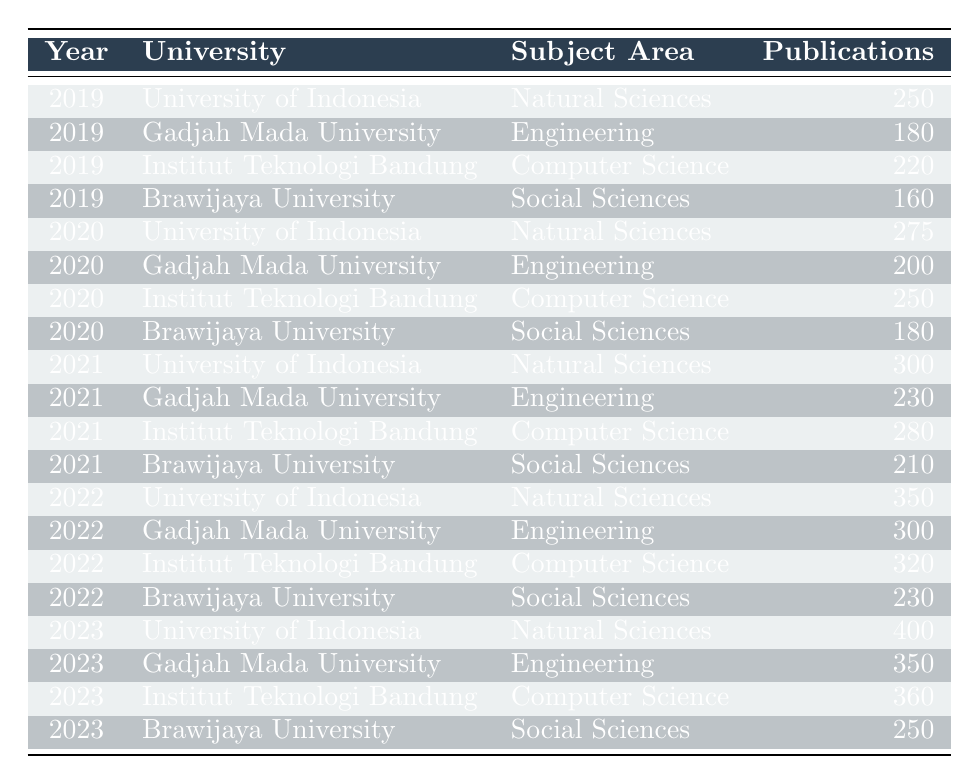What was the number of publications by the University of Indonesia in 2021? In the row for the year 2021 and the University of Indonesia, the table shows that the number of publications is 300.
Answer: 300 Which university published the most in the subject area of Computer Science in 2023? The row for the year 2023 shows that Institut Teknologi Bandung had 360 publications in Computer Science, which is higher than the other universities in that subject area.
Answer: Institut Teknologi Bandung What was the total number of publications in the subject area of Engineering from 2019 to 2023? The number of publications in Engineering over the years is: 180 (2019) + 200 (2020) + 230 (2021) + 300 (2022) + 350 (2023) = 1260.
Answer: 1260 Did Brawijaya University increase or decrease its number of publications in Social Sciences from 2019 to 2023? In 2019, Brawijaya University published 160 papers, and in 2023, it published 250. Since 250 is greater than 160, the number of publications increased.
Answer: Increased What is the average number of publications per year for the University of Indonesia from 2019 to 2023? The publications for University of Indonesia are 250 (2019), 275 (2020), 300 (2021), 350 (2022), and 400 (2023). The total is 1575, and there are 5 years, so the average is 1575/5 = 315.
Answer: 315 Which subject area had the highest total number of publications across all years? The total publications by subject area: Natural Sciences (250 + 275 + 300 + 350 + 400 = 1575), Engineering (180 + 200 + 230 + 300 + 350 = 1260), Computer Science (220 + 250 + 280 + 320 + 360 = 1430), Social Sciences (160 + 180 + 210 + 230 + 250 = 1030). Natural Sciences had the highest total at 1575.
Answer: Natural Sciences What was the year with the largest publication count for Gadjah Mada University in Engineering? Checking the rows for Gadjah Mada University in Engineering, the numbers are 180 (2019), 200 (2020), 230 (2021), 300 (2022), and 350 (2023). The largest is 350 in 2023.
Answer: 2023 Is it true that Brawijaya University had fewer publications in 2020 than in 2019? In 2019, Brawijaya University published 160 papers and in 2020, it published 180 papers. Since 180 is greater than 160, it is false that they had fewer publications in 2020 than in 2019.
Answer: False What was the increase in the number of publications from 2020 to 2021 for the subject area of Natural Sciences at the University of Indonesia? The number of publications for Natural Sciences at the University of Indonesia increased from 275 in 2020 to 300 in 2021. The difference is 300 - 275 = 25.
Answer: 25 Which university had the least number of publications in 2022? The total publications in 2022 were: University of Indonesia (350), Gadjah Mada University (300), Institut Teknologi Bandung (320), and Brawijaya University (230). Brawijaya University had the least with 230 publications.
Answer: Brawijaya University 